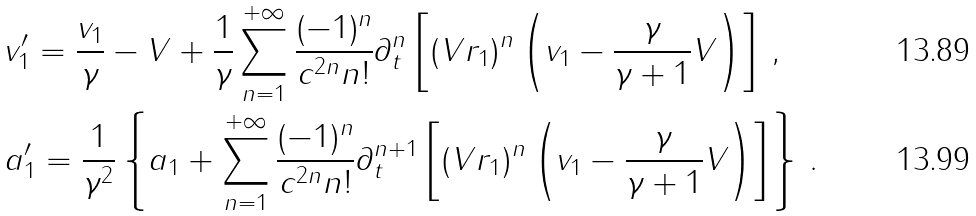<formula> <loc_0><loc_0><loc_500><loc_500>& v ^ { \prime } _ { 1 } = \frac { v _ { 1 } } { \gamma } - V + \frac { 1 } { \gamma } \sum _ { n = 1 } ^ { + \infty } \frac { ( - 1 ) ^ { n } } { c ^ { 2 n } n ! } \partial _ { t } ^ { n } \left [ ( V r _ { 1 } ) ^ { n } \left ( v _ { 1 } - \frac { \gamma } { \gamma + 1 } V \right ) \right ] \, , \\ & a ^ { \prime } _ { 1 } = \frac { 1 } { \gamma ^ { 2 } } \left \{ a _ { 1 } + \sum _ { n = 1 } ^ { + \infty } \frac { ( - 1 ) ^ { n } } { c ^ { 2 n } n ! } \partial _ { t } ^ { n + 1 } \left [ ( V r _ { 1 } ) ^ { n } \left ( v _ { 1 } - \frac { \gamma } { \gamma + 1 } V \right ) \right ] \right \} \, .</formula> 